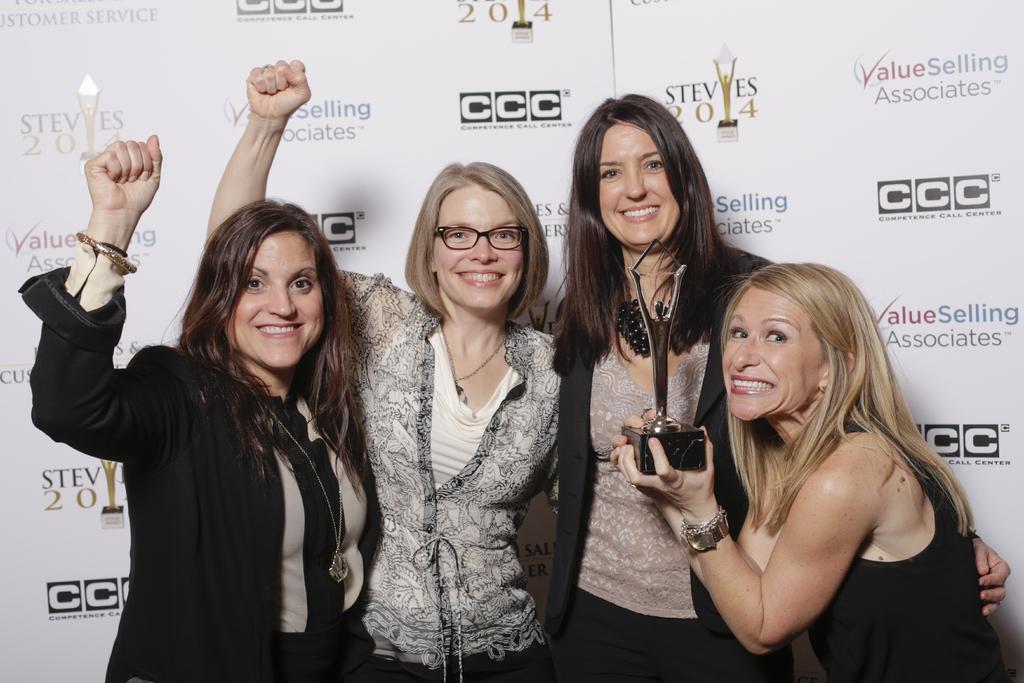Please provide a concise description of this image. In this image, there are a few people. Among them, we can see a person holding an object. In the background, we can see some boards with text and images. 